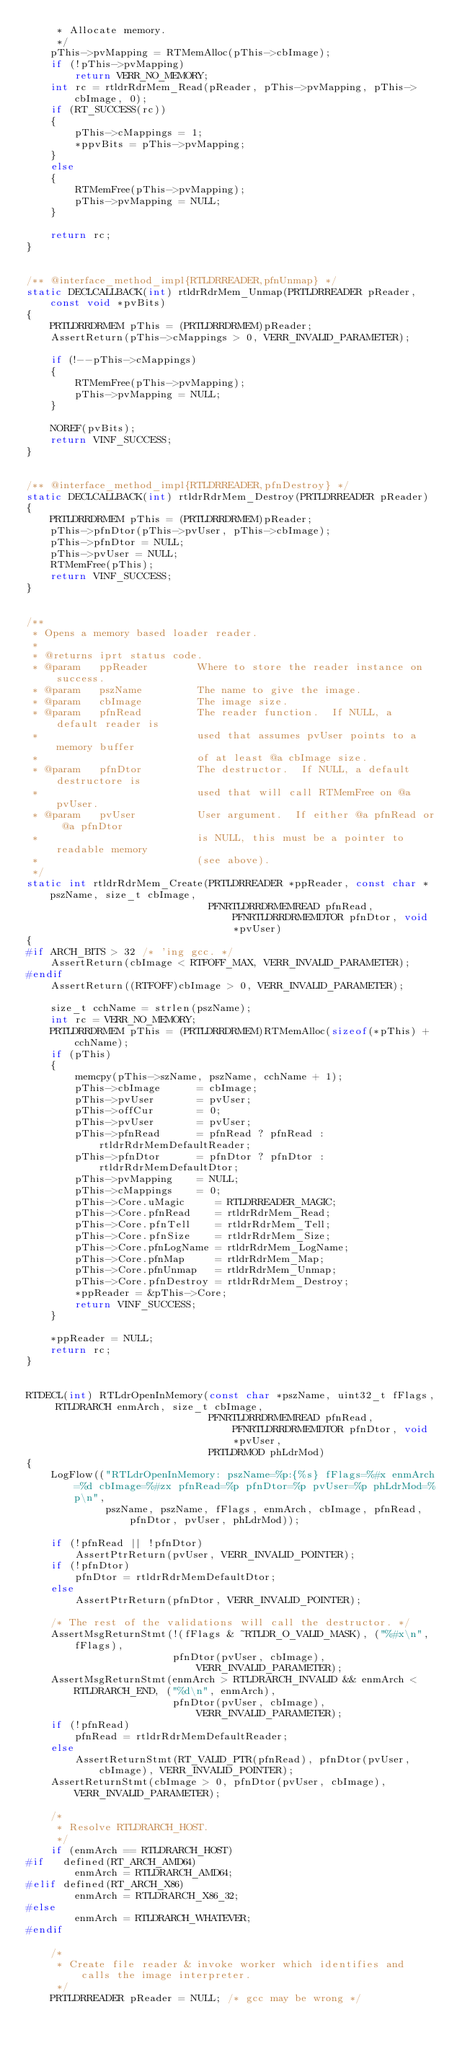<code> <loc_0><loc_0><loc_500><loc_500><_C++_>     * Allocate memory.
     */
    pThis->pvMapping = RTMemAlloc(pThis->cbImage);
    if (!pThis->pvMapping)
        return VERR_NO_MEMORY;
    int rc = rtldrRdrMem_Read(pReader, pThis->pvMapping, pThis->cbImage, 0);
    if (RT_SUCCESS(rc))
    {
        pThis->cMappings = 1;
        *ppvBits = pThis->pvMapping;
    }
    else
    {
        RTMemFree(pThis->pvMapping);
        pThis->pvMapping = NULL;
    }

    return rc;
}


/** @interface_method_impl{RTLDRREADER,pfnUnmap} */
static DECLCALLBACK(int) rtldrRdrMem_Unmap(PRTLDRREADER pReader, const void *pvBits)
{
    PRTLDRRDRMEM pThis = (PRTLDRRDRMEM)pReader;
    AssertReturn(pThis->cMappings > 0, VERR_INVALID_PARAMETER);

    if (!--pThis->cMappings)
    {
        RTMemFree(pThis->pvMapping);
        pThis->pvMapping = NULL;
    }

    NOREF(pvBits);
    return VINF_SUCCESS;
}


/** @interface_method_impl{RTLDRREADER,pfnDestroy} */
static DECLCALLBACK(int) rtldrRdrMem_Destroy(PRTLDRREADER pReader)
{
    PRTLDRRDRMEM pThis = (PRTLDRRDRMEM)pReader;
    pThis->pfnDtor(pThis->pvUser, pThis->cbImage);
    pThis->pfnDtor = NULL;
    pThis->pvUser = NULL;
    RTMemFree(pThis);
    return VINF_SUCCESS;
}


/**
 * Opens a memory based loader reader.
 *
 * @returns iprt status code.
 * @param   ppReader        Where to store the reader instance on success.
 * @param   pszName         The name to give the image.
 * @param   cbImage         The image size.
 * @param   pfnRead         The reader function.  If NULL, a default reader is
 *                          used that assumes pvUser points to a memory buffer
 *                          of at least @a cbImage size.
 * @param   pfnDtor         The destructor.  If NULL, a default destructore is
 *                          used that will call RTMemFree on @a pvUser.
 * @param   pvUser          User argument.  If either @a pfnRead or @a pfnDtor
 *                          is NULL, this must be a pointer to readable memory
 *                          (see above).
 */
static int rtldrRdrMem_Create(PRTLDRREADER *ppReader, const char *pszName, size_t cbImage,
                              PFNRTLDRRDRMEMREAD pfnRead, PFNRTLDRRDRMEMDTOR pfnDtor, void *pvUser)
{
#if ARCH_BITS > 32 /* 'ing gcc. */
    AssertReturn(cbImage < RTFOFF_MAX, VERR_INVALID_PARAMETER);
#endif
    AssertReturn((RTFOFF)cbImage > 0, VERR_INVALID_PARAMETER);

    size_t cchName = strlen(pszName);
    int rc = VERR_NO_MEMORY;
    PRTLDRRDRMEM pThis = (PRTLDRRDRMEM)RTMemAlloc(sizeof(*pThis) + cchName);
    if (pThis)
    {
        memcpy(pThis->szName, pszName, cchName + 1);
        pThis->cbImage      = cbImage;
        pThis->pvUser       = pvUser;
        pThis->offCur       = 0;
        pThis->pvUser       = pvUser;
        pThis->pfnRead      = pfnRead ? pfnRead : rtldrRdrMemDefaultReader;
        pThis->pfnDtor      = pfnDtor ? pfnDtor : rtldrRdrMemDefaultDtor;
        pThis->pvMapping    = NULL;
        pThis->cMappings    = 0;
        pThis->Core.uMagic     = RTLDRREADER_MAGIC;
        pThis->Core.pfnRead    = rtldrRdrMem_Read;
        pThis->Core.pfnTell    = rtldrRdrMem_Tell;
        pThis->Core.pfnSize    = rtldrRdrMem_Size;
        pThis->Core.pfnLogName = rtldrRdrMem_LogName;
        pThis->Core.pfnMap     = rtldrRdrMem_Map;
        pThis->Core.pfnUnmap   = rtldrRdrMem_Unmap;
        pThis->Core.pfnDestroy = rtldrRdrMem_Destroy;
        *ppReader = &pThis->Core;
        return VINF_SUCCESS;
    }

    *ppReader = NULL;
    return rc;
}


RTDECL(int) RTLdrOpenInMemory(const char *pszName, uint32_t fFlags, RTLDRARCH enmArch, size_t cbImage,
                              PFNRTLDRRDRMEMREAD pfnRead, PFNRTLDRRDRMEMDTOR pfnDtor, void *pvUser,
                              PRTLDRMOD phLdrMod)
{
    LogFlow(("RTLdrOpenInMemory: pszName=%p:{%s} fFlags=%#x enmArch=%d cbImage=%#zx pfnRead=%p pfnDtor=%p pvUser=%p phLdrMod=%p\n",
             pszName, pszName, fFlags, enmArch, cbImage, pfnRead, pfnDtor, pvUser, phLdrMod));

    if (!pfnRead || !pfnDtor)
        AssertPtrReturn(pvUser, VERR_INVALID_POINTER);
    if (!pfnDtor)
        pfnDtor = rtldrRdrMemDefaultDtor;
    else
        AssertPtrReturn(pfnDtor, VERR_INVALID_POINTER);

    /* The rest of the validations will call the destructor. */
    AssertMsgReturnStmt(!(fFlags & ~RTLDR_O_VALID_MASK), ("%#x\n", fFlags),
                        pfnDtor(pvUser, cbImage), VERR_INVALID_PARAMETER);
    AssertMsgReturnStmt(enmArch > RTLDRARCH_INVALID && enmArch < RTLDRARCH_END, ("%d\n", enmArch),
                        pfnDtor(pvUser, cbImage), VERR_INVALID_PARAMETER);
    if (!pfnRead)
        pfnRead = rtldrRdrMemDefaultReader;
    else
        AssertReturnStmt(RT_VALID_PTR(pfnRead), pfnDtor(pvUser, cbImage), VERR_INVALID_POINTER);
    AssertReturnStmt(cbImage > 0, pfnDtor(pvUser, cbImage), VERR_INVALID_PARAMETER);

    /*
     * Resolve RTLDRARCH_HOST.
     */
    if (enmArch == RTLDRARCH_HOST)
#if   defined(RT_ARCH_AMD64)
        enmArch = RTLDRARCH_AMD64;
#elif defined(RT_ARCH_X86)
        enmArch = RTLDRARCH_X86_32;
#else
        enmArch = RTLDRARCH_WHATEVER;
#endif

    /*
     * Create file reader & invoke worker which identifies and calls the image interpreter.
     */
    PRTLDRREADER pReader = NULL; /* gcc may be wrong */</code> 